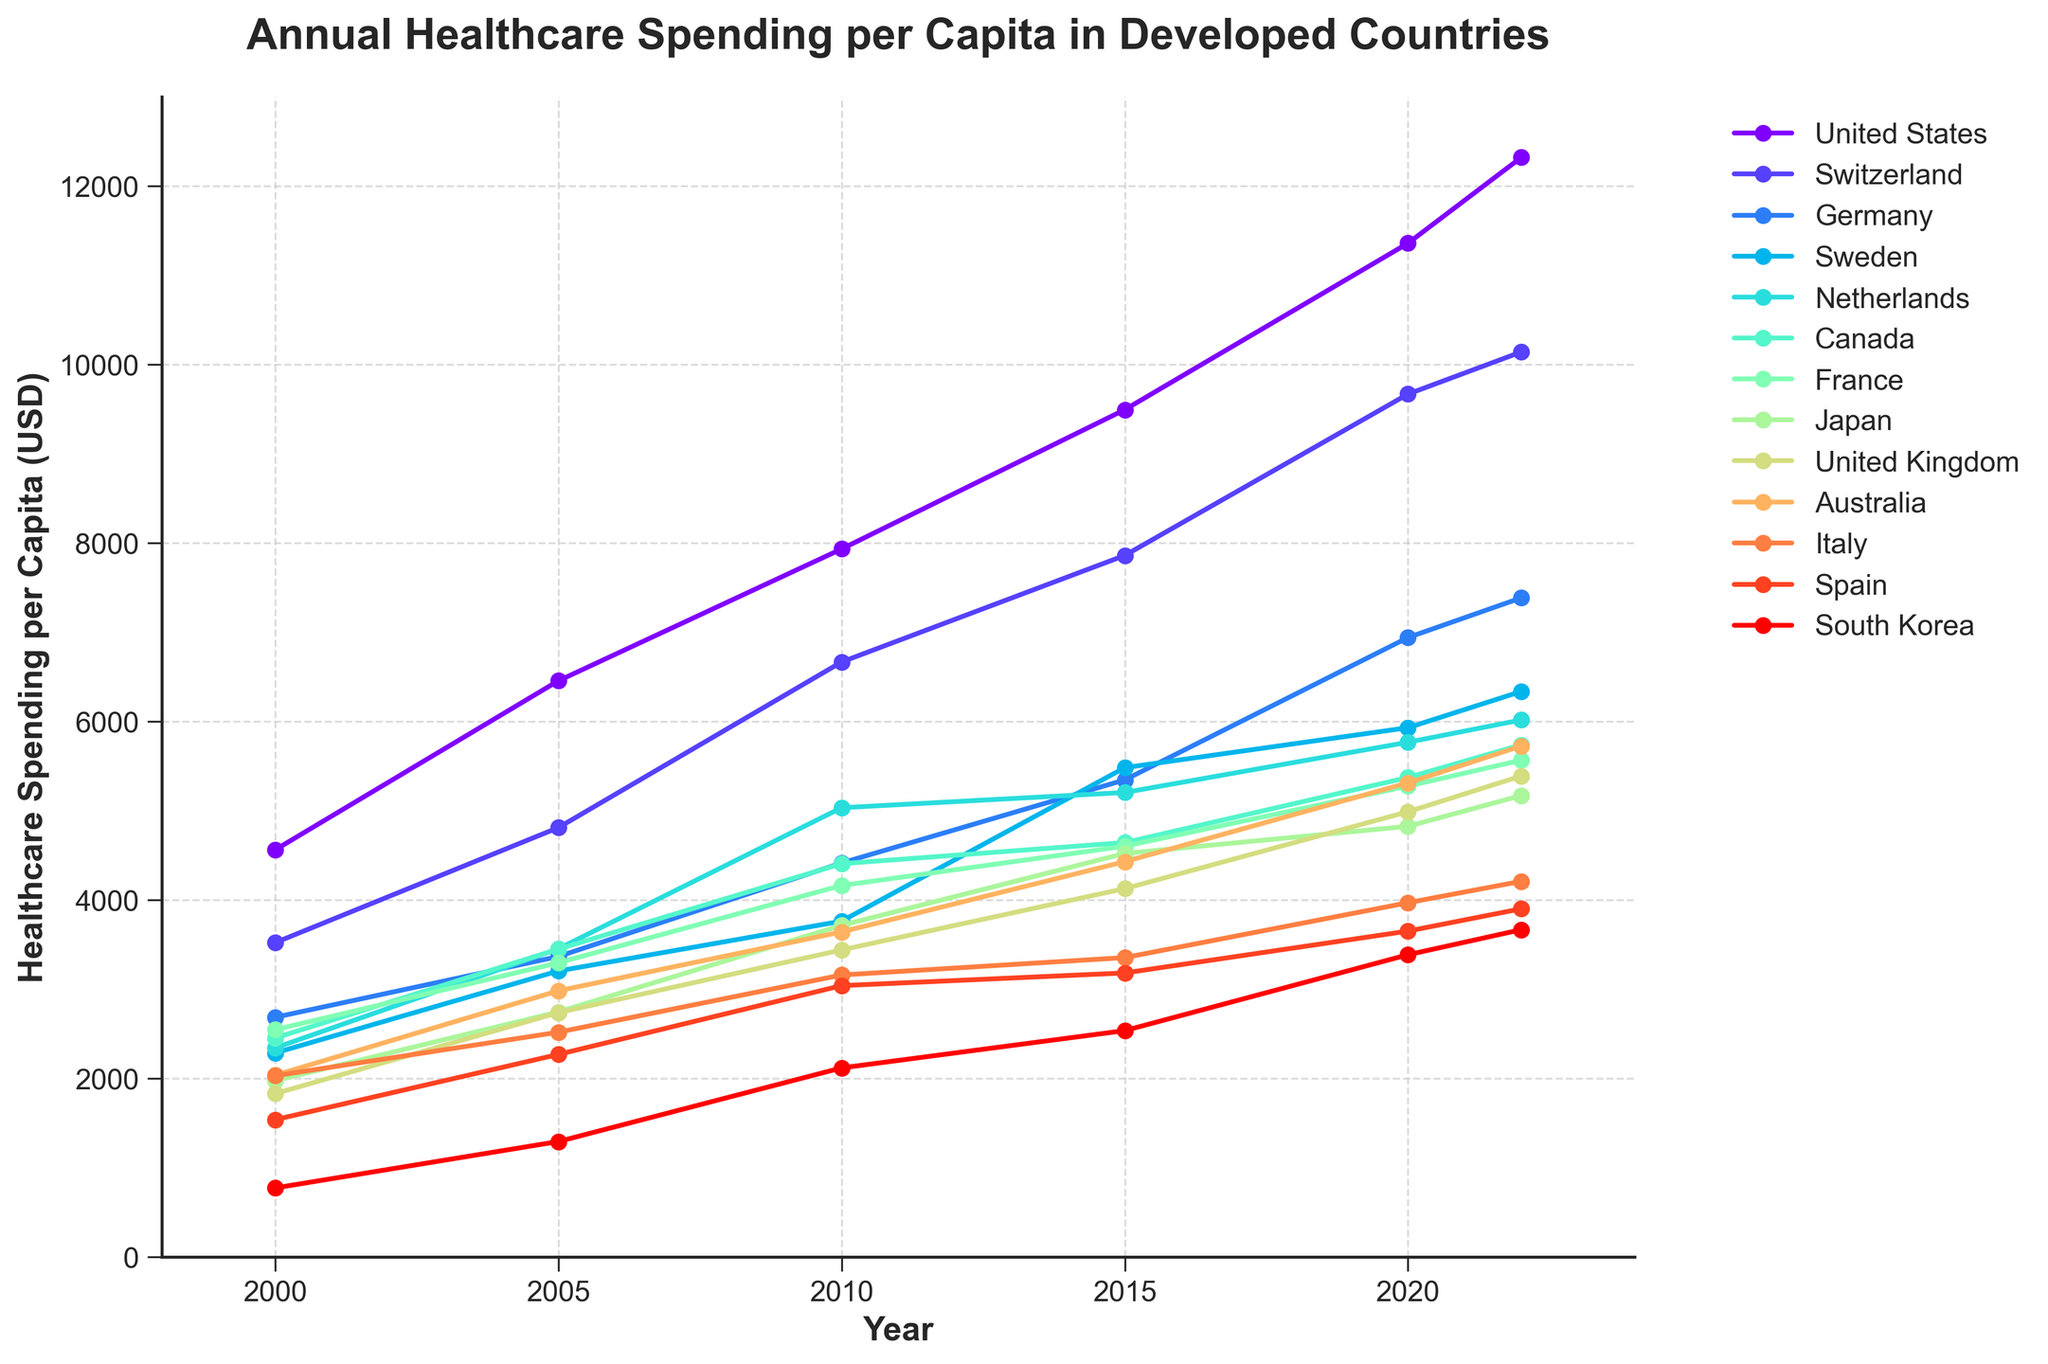Which country had the highest healthcare spending per capita in 2022? By looking at the endpoints of each line on the rightmost side of the plot corresponding to 2022, the United States line is the highest above all others.
Answer: United States Which two countries show the largest increase in healthcare spending per capita from 2000 to 2022? Calculate the increase for each country by subtracting the 2000 value from the 2022 value. The United States shows an increase of (12318 - 4559) = 7759, and Switzerland shows an increase of (10138 - 3519) = 6619. These two are the largest increases.
Answer: United States and Switzerland What is the average healthcare spending per capita in 2022 for Germany, Sweden, and the Netherlands? Sum the 2022 values for Germany (7383), Sweden (6334), and the Netherlands (6015). Then divide by 3 to find the average: (7383 + 6334 + 6015) / 3 = 19732 / 3 = 6577.33
Answer: 6577.33 Which country had the smallest increase in healthcare spending per capita between 2010 and 2022? Calculate the increase for each country by subtracting the 2010 value from the 2022 value. South Korea shows an increase of (3665 - 2116) = 1549, which is the smallest increase.
Answer: South Korea In which year did healthcare spending per capita for Canada surpass USD 5000? Look at the points plotted for Canada along the y-axis. The line for Canada crosses the 5000 mark between the years 2015 and 2020. Checking the 2020 value confirms it as 5370.
Answer: 2020 Which country had the highest percentage increase in healthcare spending per capita from 2000 to 2022? Calculate the percentage increase for each country with (2022 value - 2000 value) / 2000 value * 100. South Korea shows the highest percentage increase: (3665 - 771) / 771 * 100 = 375.81%
Answer: South Korea How does the healthcare spending per capita in Japan in 2022 compare to the United Kingdom in 2022? Compare the endpoints for Japan (5168) and the United Kingdom (5387). The United Kingdom has a higher spending per capita than Japan in 2022.
Answer: United Kingdom What is the cumulative healthcare spending per capita for Italy from 2000 to 2022 (sum of all values for each year)? Sum all the values for Italy: 2028 + 2516 + 3157 + 3352 + 3967 + 4207 = 19227
Answer: 19227 Which country's healthcare spending per capita grew more during 2005-2010, France or Australia? Compare the increase for both countries between 2005 and 2010. France: (4160 - 3294) = 866, Australia: (3640 - 2980) = 660. France had a higher growth.
Answer: France By how much did the healthcare spending per capita for Spain increase between 2020 and 2022? Subtract Spain’s 2020 value from its 2022 value: 3899 - 3649 = 250
Answer: 250 